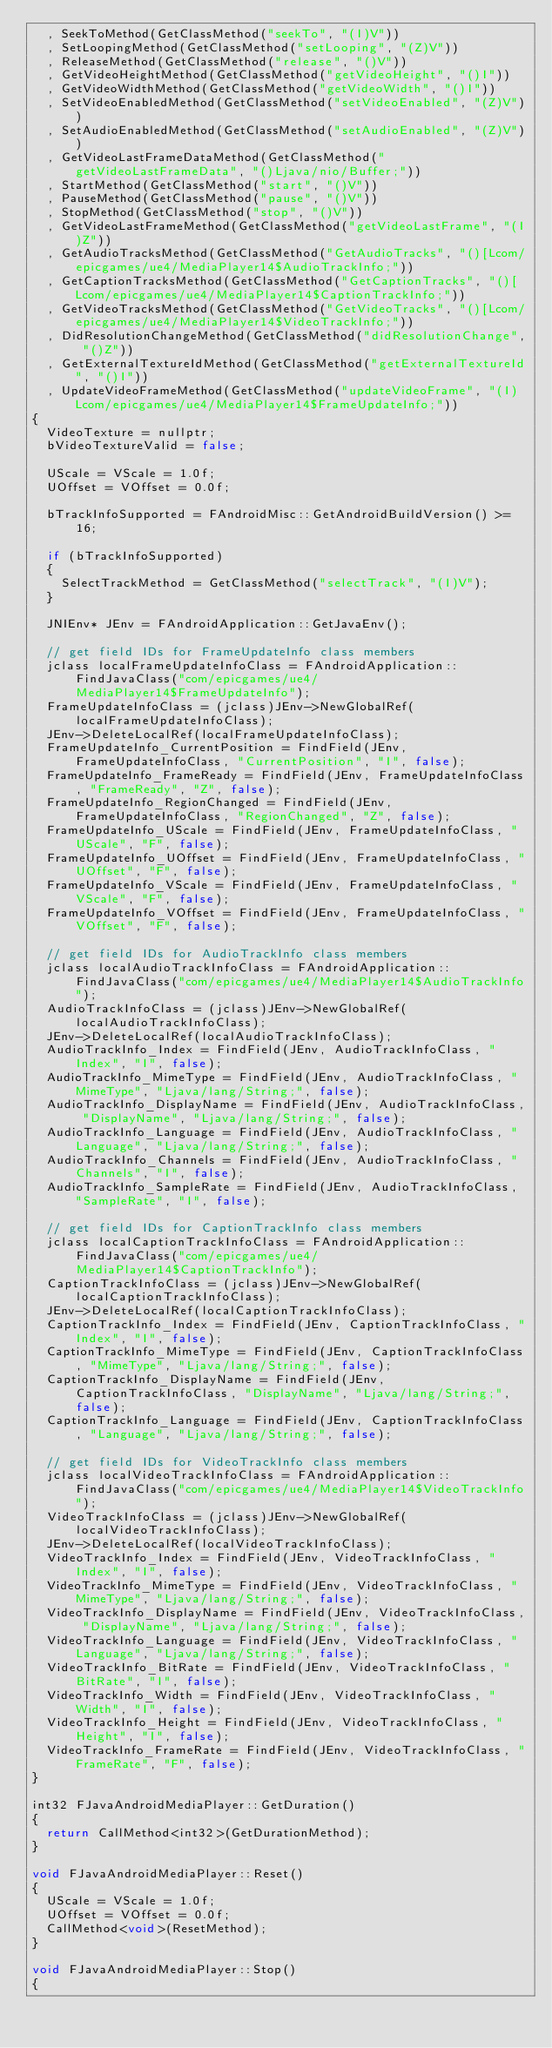Convert code to text. <code><loc_0><loc_0><loc_500><loc_500><_C++_>	, SeekToMethod(GetClassMethod("seekTo", "(I)V"))
	, SetLoopingMethod(GetClassMethod("setLooping", "(Z)V"))
	, ReleaseMethod(GetClassMethod("release", "()V"))
	, GetVideoHeightMethod(GetClassMethod("getVideoHeight", "()I"))
	, GetVideoWidthMethod(GetClassMethod("getVideoWidth", "()I"))
	, SetVideoEnabledMethod(GetClassMethod("setVideoEnabled", "(Z)V"))
	, SetAudioEnabledMethod(GetClassMethod("setAudioEnabled", "(Z)V"))
	, GetVideoLastFrameDataMethod(GetClassMethod("getVideoLastFrameData", "()Ljava/nio/Buffer;"))
	, StartMethod(GetClassMethod("start", "()V"))
	, PauseMethod(GetClassMethod("pause", "()V"))
	, StopMethod(GetClassMethod("stop", "()V"))
	, GetVideoLastFrameMethod(GetClassMethod("getVideoLastFrame", "(I)Z"))
	, GetAudioTracksMethod(GetClassMethod("GetAudioTracks", "()[Lcom/epicgames/ue4/MediaPlayer14$AudioTrackInfo;"))
	, GetCaptionTracksMethod(GetClassMethod("GetCaptionTracks", "()[Lcom/epicgames/ue4/MediaPlayer14$CaptionTrackInfo;"))
	, GetVideoTracksMethod(GetClassMethod("GetVideoTracks", "()[Lcom/epicgames/ue4/MediaPlayer14$VideoTrackInfo;"))
	, DidResolutionChangeMethod(GetClassMethod("didResolutionChange", "()Z"))
	, GetExternalTextureIdMethod(GetClassMethod("getExternalTextureId", "()I"))
	, UpdateVideoFrameMethod(GetClassMethod("updateVideoFrame", "(I)Lcom/epicgames/ue4/MediaPlayer14$FrameUpdateInfo;"))
{
	VideoTexture = nullptr;
	bVideoTextureValid = false;

	UScale = VScale = 1.0f;
	UOffset = VOffset = 0.0f;

	bTrackInfoSupported = FAndroidMisc::GetAndroidBuildVersion() >= 16;

	if (bTrackInfoSupported)
	{
		SelectTrackMethod = GetClassMethod("selectTrack", "(I)V");
	}

	JNIEnv* JEnv = FAndroidApplication::GetJavaEnv();

	// get field IDs for FrameUpdateInfo class members
	jclass localFrameUpdateInfoClass = FAndroidApplication::FindJavaClass("com/epicgames/ue4/MediaPlayer14$FrameUpdateInfo");
	FrameUpdateInfoClass = (jclass)JEnv->NewGlobalRef(localFrameUpdateInfoClass);
	JEnv->DeleteLocalRef(localFrameUpdateInfoClass);
	FrameUpdateInfo_CurrentPosition = FindField(JEnv, FrameUpdateInfoClass, "CurrentPosition", "I", false);
	FrameUpdateInfo_FrameReady = FindField(JEnv, FrameUpdateInfoClass, "FrameReady", "Z", false);
	FrameUpdateInfo_RegionChanged = FindField(JEnv, FrameUpdateInfoClass, "RegionChanged", "Z", false);
	FrameUpdateInfo_UScale = FindField(JEnv, FrameUpdateInfoClass, "UScale", "F", false);
	FrameUpdateInfo_UOffset = FindField(JEnv, FrameUpdateInfoClass, "UOffset", "F", false);
	FrameUpdateInfo_VScale = FindField(JEnv, FrameUpdateInfoClass, "VScale", "F", false);
	FrameUpdateInfo_VOffset = FindField(JEnv, FrameUpdateInfoClass, "VOffset", "F", false);

	// get field IDs for AudioTrackInfo class members
	jclass localAudioTrackInfoClass = FAndroidApplication::FindJavaClass("com/epicgames/ue4/MediaPlayer14$AudioTrackInfo");
	AudioTrackInfoClass = (jclass)JEnv->NewGlobalRef(localAudioTrackInfoClass);
	JEnv->DeleteLocalRef(localAudioTrackInfoClass);
	AudioTrackInfo_Index = FindField(JEnv, AudioTrackInfoClass, "Index", "I", false);
	AudioTrackInfo_MimeType = FindField(JEnv, AudioTrackInfoClass, "MimeType", "Ljava/lang/String;", false);
	AudioTrackInfo_DisplayName = FindField(JEnv, AudioTrackInfoClass, "DisplayName", "Ljava/lang/String;", false);
	AudioTrackInfo_Language = FindField(JEnv, AudioTrackInfoClass, "Language", "Ljava/lang/String;", false);
	AudioTrackInfo_Channels = FindField(JEnv, AudioTrackInfoClass, "Channels", "I", false);
	AudioTrackInfo_SampleRate = FindField(JEnv, AudioTrackInfoClass, "SampleRate", "I", false);

	// get field IDs for CaptionTrackInfo class members
	jclass localCaptionTrackInfoClass = FAndroidApplication::FindJavaClass("com/epicgames/ue4/MediaPlayer14$CaptionTrackInfo");
	CaptionTrackInfoClass = (jclass)JEnv->NewGlobalRef(localCaptionTrackInfoClass);
	JEnv->DeleteLocalRef(localCaptionTrackInfoClass);
	CaptionTrackInfo_Index = FindField(JEnv, CaptionTrackInfoClass, "Index", "I", false);
	CaptionTrackInfo_MimeType = FindField(JEnv, CaptionTrackInfoClass, "MimeType", "Ljava/lang/String;", false);
	CaptionTrackInfo_DisplayName = FindField(JEnv, CaptionTrackInfoClass, "DisplayName", "Ljava/lang/String;", false);
	CaptionTrackInfo_Language = FindField(JEnv, CaptionTrackInfoClass, "Language", "Ljava/lang/String;", false);

	// get field IDs for VideoTrackInfo class members
	jclass localVideoTrackInfoClass = FAndroidApplication::FindJavaClass("com/epicgames/ue4/MediaPlayer14$VideoTrackInfo");
	VideoTrackInfoClass = (jclass)JEnv->NewGlobalRef(localVideoTrackInfoClass);
	JEnv->DeleteLocalRef(localVideoTrackInfoClass);
	VideoTrackInfo_Index = FindField(JEnv, VideoTrackInfoClass, "Index", "I", false);
	VideoTrackInfo_MimeType = FindField(JEnv, VideoTrackInfoClass, "MimeType", "Ljava/lang/String;", false);
	VideoTrackInfo_DisplayName = FindField(JEnv, VideoTrackInfoClass, "DisplayName", "Ljava/lang/String;", false);
	VideoTrackInfo_Language = FindField(JEnv, VideoTrackInfoClass, "Language", "Ljava/lang/String;", false);
	VideoTrackInfo_BitRate = FindField(JEnv, VideoTrackInfoClass, "BitRate", "I", false);
	VideoTrackInfo_Width = FindField(JEnv, VideoTrackInfoClass, "Width", "I", false);
	VideoTrackInfo_Height = FindField(JEnv, VideoTrackInfoClass, "Height", "I", false);
	VideoTrackInfo_FrameRate = FindField(JEnv, VideoTrackInfoClass, "FrameRate", "F", false);
}

int32 FJavaAndroidMediaPlayer::GetDuration()
{
	return CallMethod<int32>(GetDurationMethod);
}

void FJavaAndroidMediaPlayer::Reset()
{
	UScale = VScale = 1.0f;
	UOffset = VOffset = 0.0f;
	CallMethod<void>(ResetMethod);
}

void FJavaAndroidMediaPlayer::Stop()
{</code> 